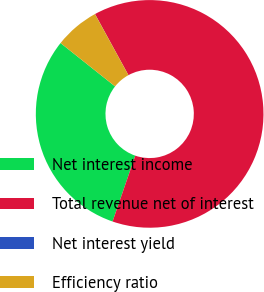<chart> <loc_0><loc_0><loc_500><loc_500><pie_chart><fcel>Net interest income<fcel>Total revenue net of interest<fcel>Net interest yield<fcel>Efficiency ratio<nl><fcel>30.41%<fcel>63.25%<fcel>0.01%<fcel>6.33%<nl></chart> 